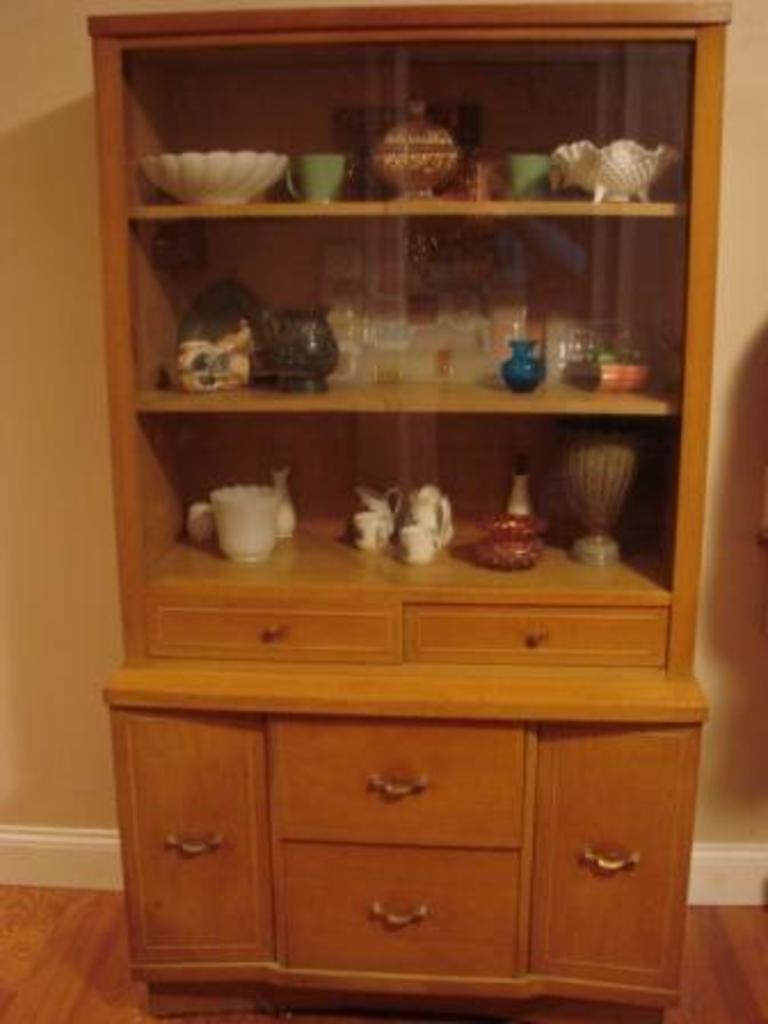How would you summarize this image in a sentence or two? In the center of this picture we can see a wooden cabinet containing cups, jars, bowls and some other objects. In the background we can see the wall and the floor. 